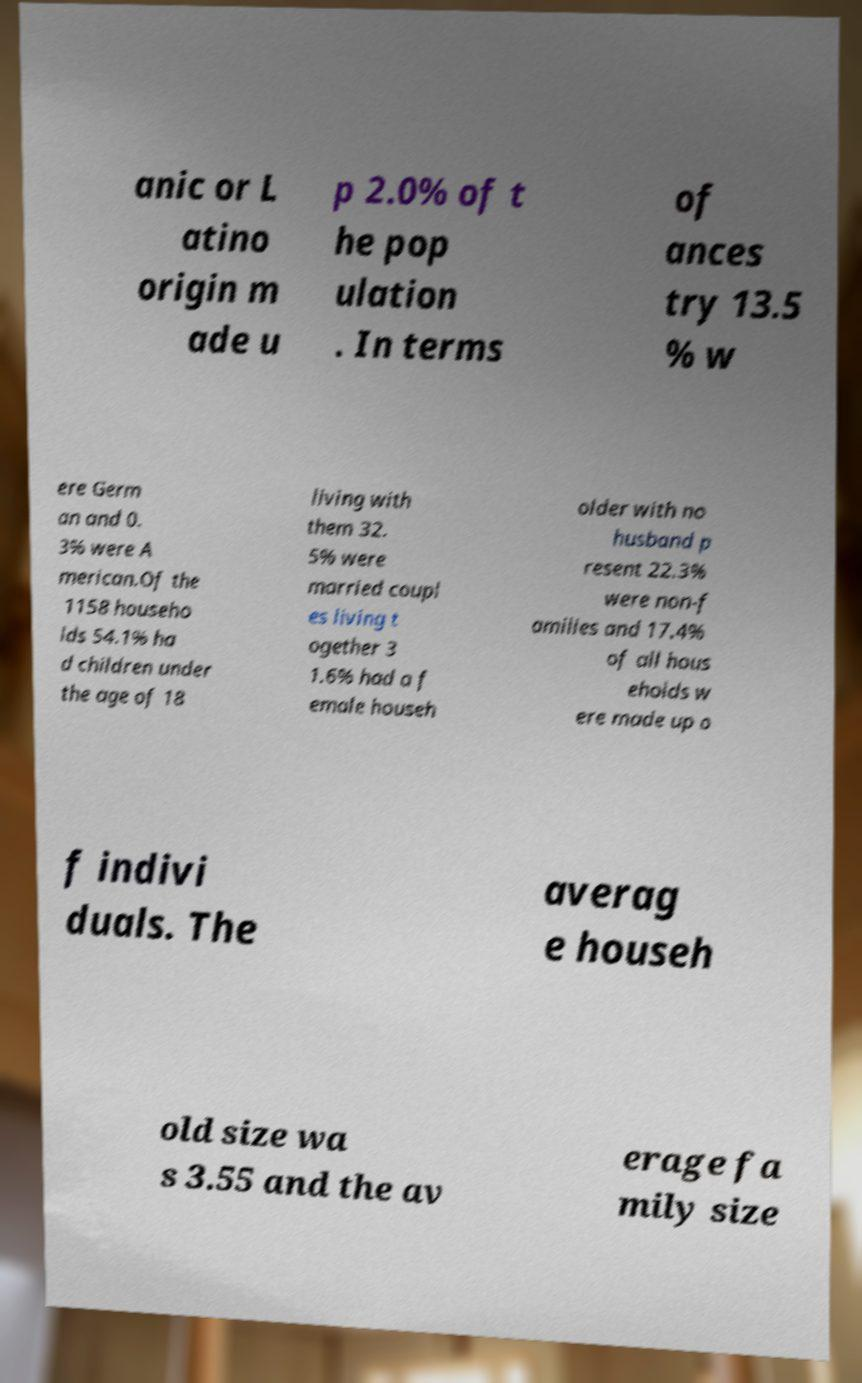I need the written content from this picture converted into text. Can you do that? anic or L atino origin m ade u p 2.0% of t he pop ulation . In terms of ances try 13.5 % w ere Germ an and 0. 3% were A merican.Of the 1158 househo lds 54.1% ha d children under the age of 18 living with them 32. 5% were married coupl es living t ogether 3 1.6% had a f emale househ older with no husband p resent 22.3% were non-f amilies and 17.4% of all hous eholds w ere made up o f indivi duals. The averag e househ old size wa s 3.55 and the av erage fa mily size 